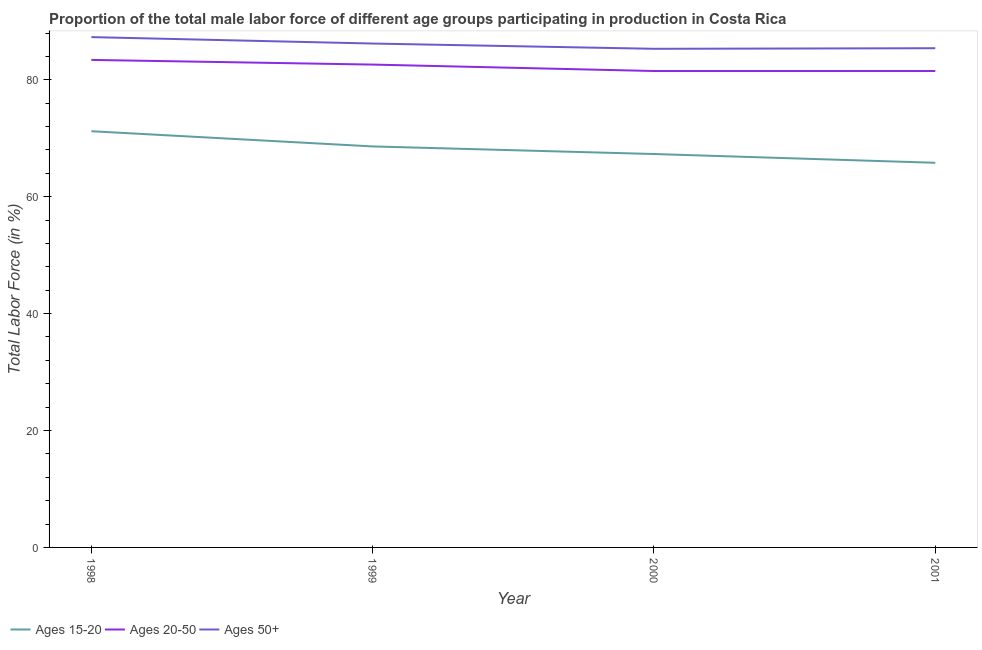Does the line corresponding to percentage of male labor force within the age group 20-50 intersect with the line corresponding to percentage of male labor force above age 50?
Provide a succinct answer. No. What is the percentage of male labor force within the age group 20-50 in 2001?
Offer a very short reply. 81.5. Across all years, what is the maximum percentage of male labor force above age 50?
Offer a terse response. 87.3. Across all years, what is the minimum percentage of male labor force within the age group 20-50?
Ensure brevity in your answer.  81.5. In which year was the percentage of male labor force within the age group 20-50 maximum?
Give a very brief answer. 1998. What is the total percentage of male labor force above age 50 in the graph?
Offer a very short reply. 344.2. What is the difference between the percentage of male labor force within the age group 20-50 in 1998 and that in 1999?
Provide a short and direct response. 0.8. What is the difference between the percentage of male labor force above age 50 in 1998 and the percentage of male labor force within the age group 15-20 in 2000?
Give a very brief answer. 20. What is the average percentage of male labor force within the age group 15-20 per year?
Your response must be concise. 68.23. In the year 2001, what is the difference between the percentage of male labor force within the age group 20-50 and percentage of male labor force within the age group 15-20?
Give a very brief answer. 15.7. What is the ratio of the percentage of male labor force above age 50 in 1999 to that in 2000?
Your answer should be very brief. 1.01. Is the difference between the percentage of male labor force within the age group 15-20 in 2000 and 2001 greater than the difference between the percentage of male labor force above age 50 in 2000 and 2001?
Offer a very short reply. Yes. What is the difference between the highest and the second highest percentage of male labor force above age 50?
Your response must be concise. 1.1. What is the difference between the highest and the lowest percentage of male labor force within the age group 15-20?
Give a very brief answer. 5.4. Is the sum of the percentage of male labor force within the age group 15-20 in 1998 and 1999 greater than the maximum percentage of male labor force above age 50 across all years?
Keep it short and to the point. Yes. Does the percentage of male labor force above age 50 monotonically increase over the years?
Provide a succinct answer. No. Is the percentage of male labor force within the age group 15-20 strictly greater than the percentage of male labor force above age 50 over the years?
Your response must be concise. No. Is the percentage of male labor force within the age group 15-20 strictly less than the percentage of male labor force within the age group 20-50 over the years?
Your answer should be compact. Yes. How many lines are there?
Ensure brevity in your answer.  3. What is the difference between two consecutive major ticks on the Y-axis?
Your answer should be compact. 20. Are the values on the major ticks of Y-axis written in scientific E-notation?
Provide a succinct answer. No. Where does the legend appear in the graph?
Make the answer very short. Bottom left. What is the title of the graph?
Offer a very short reply. Proportion of the total male labor force of different age groups participating in production in Costa Rica. What is the label or title of the X-axis?
Your answer should be very brief. Year. What is the label or title of the Y-axis?
Give a very brief answer. Total Labor Force (in %). What is the Total Labor Force (in %) of Ages 15-20 in 1998?
Provide a succinct answer. 71.2. What is the Total Labor Force (in %) of Ages 20-50 in 1998?
Keep it short and to the point. 83.4. What is the Total Labor Force (in %) in Ages 50+ in 1998?
Your answer should be compact. 87.3. What is the Total Labor Force (in %) of Ages 15-20 in 1999?
Give a very brief answer. 68.6. What is the Total Labor Force (in %) in Ages 20-50 in 1999?
Provide a short and direct response. 82.6. What is the Total Labor Force (in %) of Ages 50+ in 1999?
Offer a very short reply. 86.2. What is the Total Labor Force (in %) in Ages 15-20 in 2000?
Provide a short and direct response. 67.3. What is the Total Labor Force (in %) in Ages 20-50 in 2000?
Make the answer very short. 81.5. What is the Total Labor Force (in %) in Ages 50+ in 2000?
Provide a short and direct response. 85.3. What is the Total Labor Force (in %) of Ages 15-20 in 2001?
Your answer should be very brief. 65.8. What is the Total Labor Force (in %) in Ages 20-50 in 2001?
Ensure brevity in your answer.  81.5. What is the Total Labor Force (in %) in Ages 50+ in 2001?
Provide a short and direct response. 85.4. Across all years, what is the maximum Total Labor Force (in %) in Ages 15-20?
Give a very brief answer. 71.2. Across all years, what is the maximum Total Labor Force (in %) in Ages 20-50?
Your answer should be compact. 83.4. Across all years, what is the maximum Total Labor Force (in %) in Ages 50+?
Provide a succinct answer. 87.3. Across all years, what is the minimum Total Labor Force (in %) of Ages 15-20?
Your answer should be very brief. 65.8. Across all years, what is the minimum Total Labor Force (in %) in Ages 20-50?
Offer a terse response. 81.5. Across all years, what is the minimum Total Labor Force (in %) in Ages 50+?
Provide a succinct answer. 85.3. What is the total Total Labor Force (in %) in Ages 15-20 in the graph?
Give a very brief answer. 272.9. What is the total Total Labor Force (in %) in Ages 20-50 in the graph?
Make the answer very short. 329. What is the total Total Labor Force (in %) in Ages 50+ in the graph?
Your answer should be compact. 344.2. What is the difference between the Total Labor Force (in %) of Ages 50+ in 1998 and that in 1999?
Give a very brief answer. 1.1. What is the difference between the Total Labor Force (in %) in Ages 20-50 in 1998 and that in 2000?
Provide a short and direct response. 1.9. What is the difference between the Total Labor Force (in %) in Ages 50+ in 1998 and that in 2000?
Provide a succinct answer. 2. What is the difference between the Total Labor Force (in %) in Ages 15-20 in 1998 and that in 2001?
Your answer should be compact. 5.4. What is the difference between the Total Labor Force (in %) of Ages 50+ in 1998 and that in 2001?
Ensure brevity in your answer.  1.9. What is the difference between the Total Labor Force (in %) of Ages 20-50 in 1999 and that in 2000?
Provide a succinct answer. 1.1. What is the difference between the Total Labor Force (in %) in Ages 50+ in 1999 and that in 2000?
Provide a short and direct response. 0.9. What is the difference between the Total Labor Force (in %) of Ages 15-20 in 1999 and that in 2001?
Keep it short and to the point. 2.8. What is the difference between the Total Labor Force (in %) in Ages 20-50 in 1999 and that in 2001?
Your answer should be compact. 1.1. What is the difference between the Total Labor Force (in %) of Ages 20-50 in 2000 and that in 2001?
Keep it short and to the point. 0. What is the difference between the Total Labor Force (in %) in Ages 15-20 in 1998 and the Total Labor Force (in %) in Ages 50+ in 1999?
Ensure brevity in your answer.  -15. What is the difference between the Total Labor Force (in %) of Ages 15-20 in 1998 and the Total Labor Force (in %) of Ages 20-50 in 2000?
Your response must be concise. -10.3. What is the difference between the Total Labor Force (in %) in Ages 15-20 in 1998 and the Total Labor Force (in %) in Ages 50+ in 2000?
Give a very brief answer. -14.1. What is the difference between the Total Labor Force (in %) in Ages 20-50 in 1998 and the Total Labor Force (in %) in Ages 50+ in 2000?
Your response must be concise. -1.9. What is the difference between the Total Labor Force (in %) in Ages 15-20 in 1998 and the Total Labor Force (in %) in Ages 20-50 in 2001?
Offer a terse response. -10.3. What is the difference between the Total Labor Force (in %) in Ages 20-50 in 1998 and the Total Labor Force (in %) in Ages 50+ in 2001?
Offer a terse response. -2. What is the difference between the Total Labor Force (in %) in Ages 15-20 in 1999 and the Total Labor Force (in %) in Ages 50+ in 2000?
Provide a succinct answer. -16.7. What is the difference between the Total Labor Force (in %) in Ages 20-50 in 1999 and the Total Labor Force (in %) in Ages 50+ in 2000?
Your answer should be compact. -2.7. What is the difference between the Total Labor Force (in %) of Ages 15-20 in 1999 and the Total Labor Force (in %) of Ages 50+ in 2001?
Ensure brevity in your answer.  -16.8. What is the difference between the Total Labor Force (in %) in Ages 15-20 in 2000 and the Total Labor Force (in %) in Ages 50+ in 2001?
Make the answer very short. -18.1. What is the average Total Labor Force (in %) of Ages 15-20 per year?
Make the answer very short. 68.22. What is the average Total Labor Force (in %) of Ages 20-50 per year?
Your response must be concise. 82.25. What is the average Total Labor Force (in %) in Ages 50+ per year?
Make the answer very short. 86.05. In the year 1998, what is the difference between the Total Labor Force (in %) in Ages 15-20 and Total Labor Force (in %) in Ages 50+?
Your answer should be very brief. -16.1. In the year 1999, what is the difference between the Total Labor Force (in %) in Ages 15-20 and Total Labor Force (in %) in Ages 20-50?
Keep it short and to the point. -14. In the year 1999, what is the difference between the Total Labor Force (in %) of Ages 15-20 and Total Labor Force (in %) of Ages 50+?
Provide a succinct answer. -17.6. In the year 2000, what is the difference between the Total Labor Force (in %) in Ages 15-20 and Total Labor Force (in %) in Ages 50+?
Give a very brief answer. -18. In the year 2001, what is the difference between the Total Labor Force (in %) in Ages 15-20 and Total Labor Force (in %) in Ages 20-50?
Ensure brevity in your answer.  -15.7. In the year 2001, what is the difference between the Total Labor Force (in %) of Ages 15-20 and Total Labor Force (in %) of Ages 50+?
Provide a short and direct response. -19.6. What is the ratio of the Total Labor Force (in %) in Ages 15-20 in 1998 to that in 1999?
Ensure brevity in your answer.  1.04. What is the ratio of the Total Labor Force (in %) of Ages 20-50 in 1998 to that in 1999?
Your answer should be very brief. 1.01. What is the ratio of the Total Labor Force (in %) of Ages 50+ in 1998 to that in 1999?
Your answer should be compact. 1.01. What is the ratio of the Total Labor Force (in %) in Ages 15-20 in 1998 to that in 2000?
Ensure brevity in your answer.  1.06. What is the ratio of the Total Labor Force (in %) of Ages 20-50 in 1998 to that in 2000?
Provide a succinct answer. 1.02. What is the ratio of the Total Labor Force (in %) in Ages 50+ in 1998 to that in 2000?
Offer a terse response. 1.02. What is the ratio of the Total Labor Force (in %) of Ages 15-20 in 1998 to that in 2001?
Give a very brief answer. 1.08. What is the ratio of the Total Labor Force (in %) of Ages 20-50 in 1998 to that in 2001?
Make the answer very short. 1.02. What is the ratio of the Total Labor Force (in %) of Ages 50+ in 1998 to that in 2001?
Give a very brief answer. 1.02. What is the ratio of the Total Labor Force (in %) of Ages 15-20 in 1999 to that in 2000?
Make the answer very short. 1.02. What is the ratio of the Total Labor Force (in %) in Ages 20-50 in 1999 to that in 2000?
Ensure brevity in your answer.  1.01. What is the ratio of the Total Labor Force (in %) of Ages 50+ in 1999 to that in 2000?
Provide a succinct answer. 1.01. What is the ratio of the Total Labor Force (in %) in Ages 15-20 in 1999 to that in 2001?
Give a very brief answer. 1.04. What is the ratio of the Total Labor Force (in %) of Ages 20-50 in 1999 to that in 2001?
Make the answer very short. 1.01. What is the ratio of the Total Labor Force (in %) of Ages 50+ in 1999 to that in 2001?
Keep it short and to the point. 1.01. What is the ratio of the Total Labor Force (in %) in Ages 15-20 in 2000 to that in 2001?
Your answer should be very brief. 1.02. What is the ratio of the Total Labor Force (in %) of Ages 20-50 in 2000 to that in 2001?
Give a very brief answer. 1. What is the ratio of the Total Labor Force (in %) in Ages 50+ in 2000 to that in 2001?
Make the answer very short. 1. What is the difference between the highest and the second highest Total Labor Force (in %) in Ages 15-20?
Your answer should be compact. 2.6. What is the difference between the highest and the second highest Total Labor Force (in %) of Ages 20-50?
Your answer should be very brief. 0.8. What is the difference between the highest and the second highest Total Labor Force (in %) of Ages 50+?
Your response must be concise. 1.1. What is the difference between the highest and the lowest Total Labor Force (in %) of Ages 15-20?
Keep it short and to the point. 5.4. What is the difference between the highest and the lowest Total Labor Force (in %) of Ages 50+?
Provide a succinct answer. 2. 